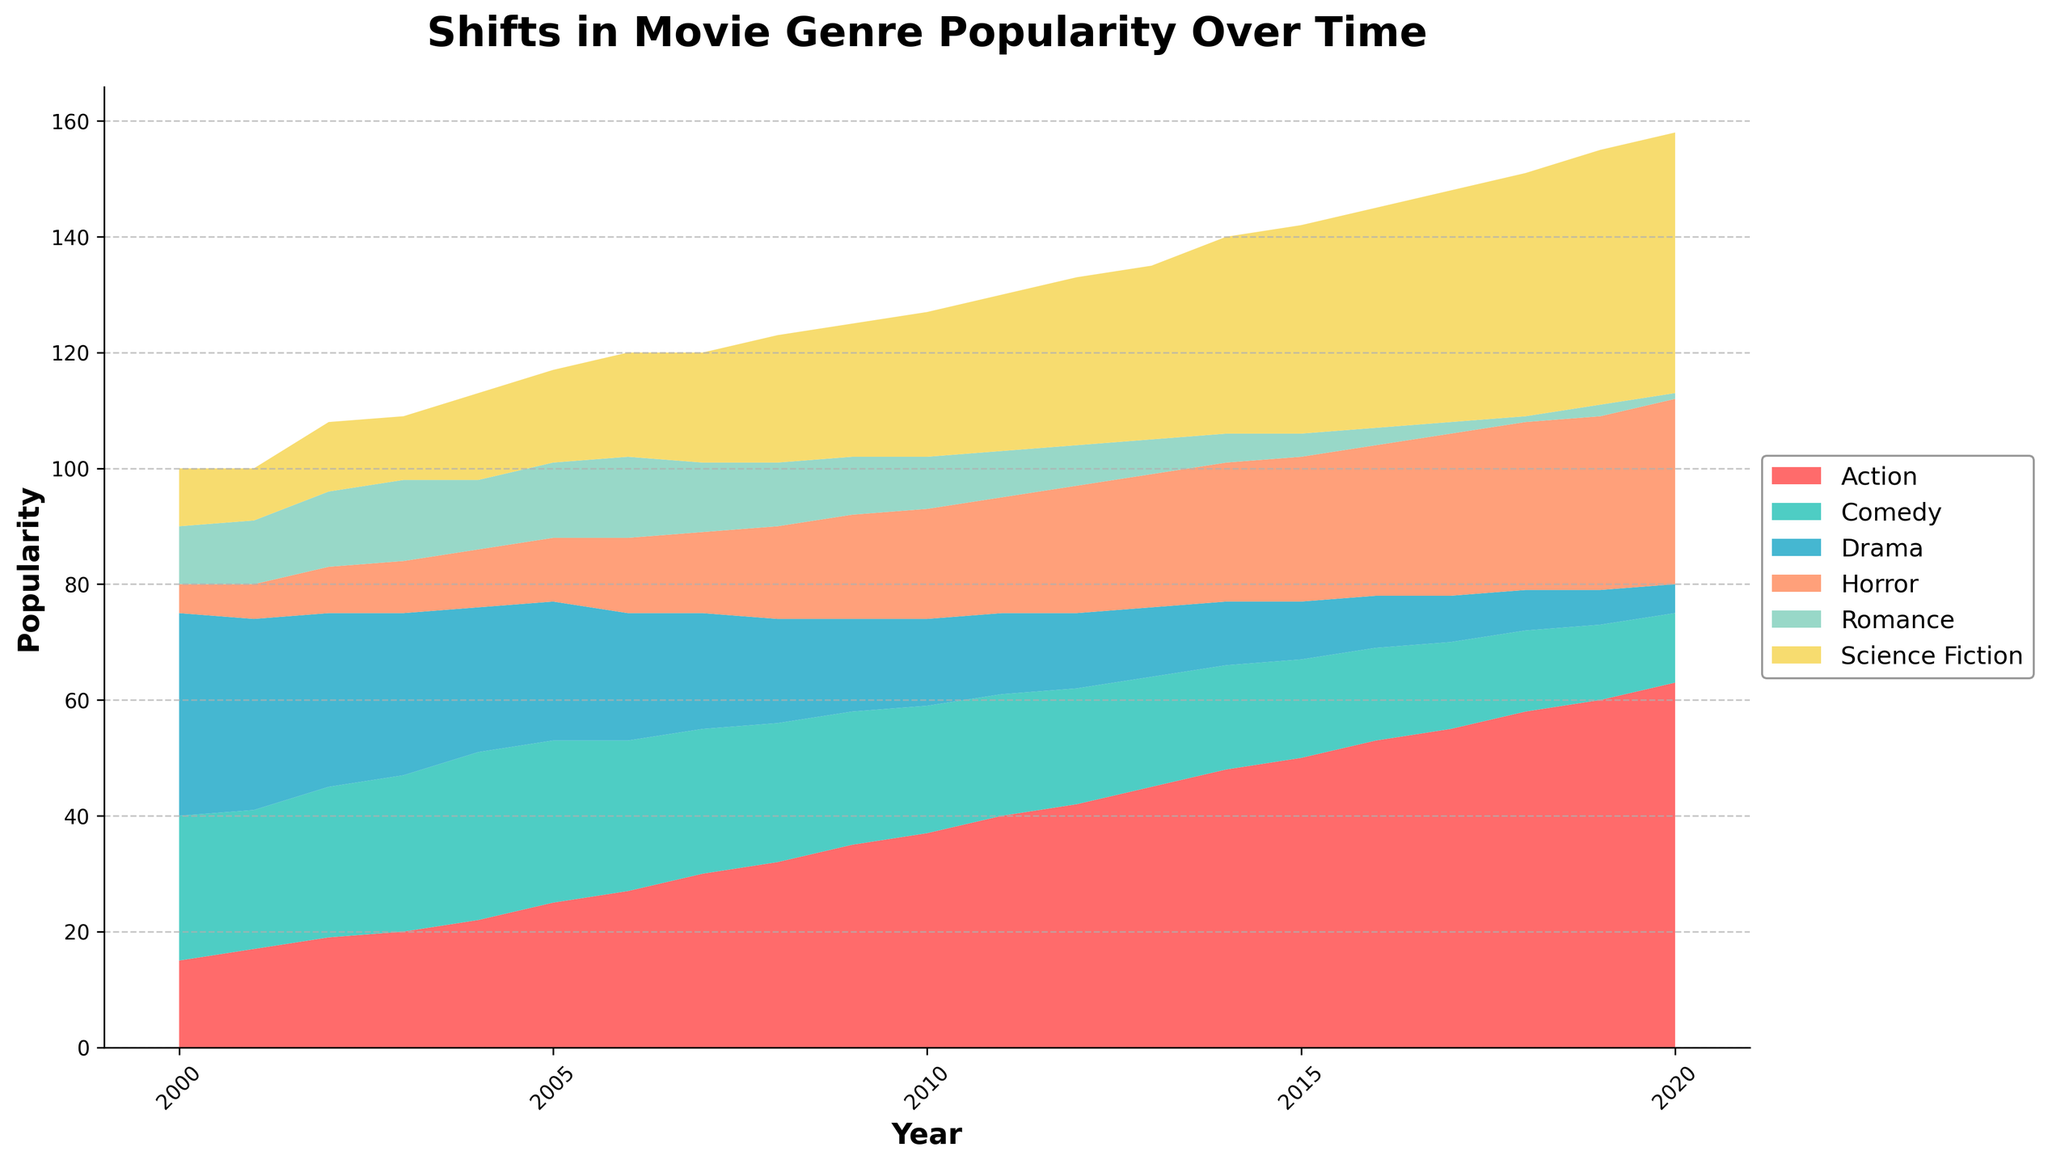What is the title of the figure? The title is usually located at the top of the figure and provides a brief description of what the graph is about.
Answer: Shifts in Movie Genre Popularity Over Time Which genre has the highest popularity in 2020 according to the graph? Look at the 2020 mark on the x-axis and observe the heights of the areas for each genre. The tallest area represents the most popular genre.
Answer: Action How did the popularity of Science Fiction change from 2000 to 2020? Observe the height of the Science Fiction area in 2000 and compare it to its height in 2020. Note whether it increased, decreased, or stayed the same.
Answer: Increased During which year did Drama have the lowest popularity? Follow the Drama area across the timeline and identify the year where the area is the smallest.
Answer: 2020 Compare the popularity of Horror and Romance genres in 2012. Which one was more popular? Look at the 2012 mark on the x-axis and compare the heights of the Horror and Romance areas. The genre with the taller area is more popular.
Answer: Horror What is the general trend observed in the popularity of Comedy over the years? Observe the height of the Comedy area throughout the plotted years and note if it is generally increasing, decreasing, or staying the same.
Answer: Decreasing In which year did Action overtake Drama in popularity for the first time? Trace the respective areas of Action and Drama and find the year where the Action area becomes taller than the Drama area.
Answer: 2002 Which genre experienced the most growth from 2000 to 2020? Calculate the difference in the height of each genre area from 2000 to 2020 and identify the genre with the largest increase.
Answer: Science Fiction How does the popularity of Romance in 2019 compare to its popularity in 2004? Compare the height of the Romance area in 2019 with its height in 2004 by aligning with the y-axis.
Answer: Lower in 2019 Among Action, Comedy, and Drama, which genre declined the most in popularity from 2000 to 2020? Evaluate the changes in the areas of Action, Comedy, and Drama from 2000 to 2020 and identify the genre with the largest decrease.
Answer: Drama 